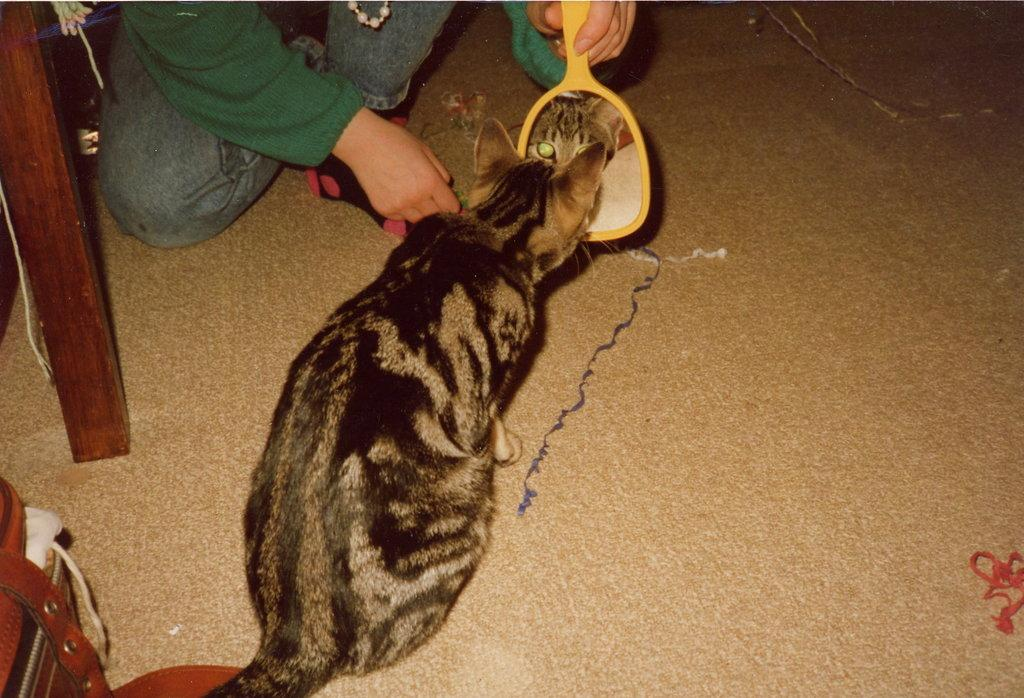What type of animal is in the image? There is a cat in the image. What is the person holding in the image? The person is holding a mirror in the image. What does the mirror reflect in the image? The mirror reflects a cat in the image. What can be seen on the floor in the image? There are objects on the floor in the image. What type of payment is required to attend the school in the image? There is no school or payment mentioned in the image; it only features a cat and a person holding a mirror. 